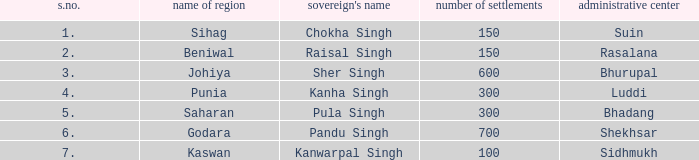What is the highest S number with a capital of Shekhsar? 6.0. 